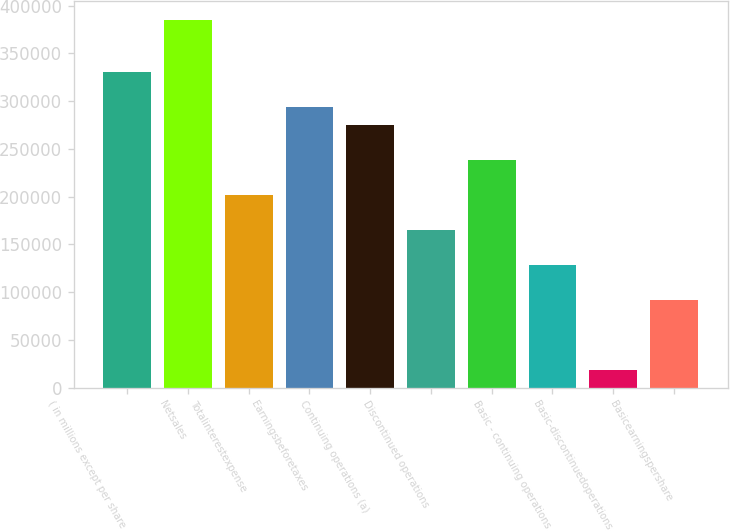Convert chart to OTSL. <chart><loc_0><loc_0><loc_500><loc_500><bar_chart><fcel>( in millions except per share<fcel>Netsales<fcel>Totalinterestexpense<fcel>Earningsbeforetaxes<fcel>Continuing operations (a)<fcel>Discontinued operations<fcel>Unnamed: 6<fcel>Basic - continuing operations<fcel>Basic-discontinuedoperations<fcel>Basicearningspershare<nl><fcel>330368<fcel>385430<fcel>201892<fcel>293661<fcel>275307<fcel>165184<fcel>238599<fcel>128477<fcel>18354<fcel>91769.1<nl></chart> 